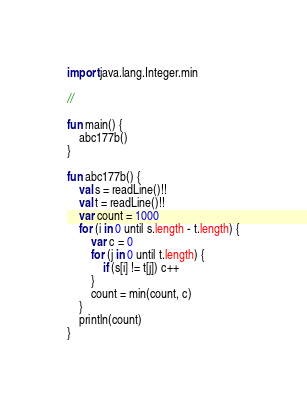Convert code to text. <code><loc_0><loc_0><loc_500><loc_500><_Kotlin_>import java.lang.Integer.min

//

fun main() {
    abc177b()
}

fun abc177b() {
    val s = readLine()!!
    val t = readLine()!!
    var count = 1000
    for (i in 0 until s.length - t.length) {
        var c = 0
        for (j in 0 until t.length) {
            if (s[i] != t[j]) c++
        }
        count = min(count, c)
    }
    println(count)
}
</code> 